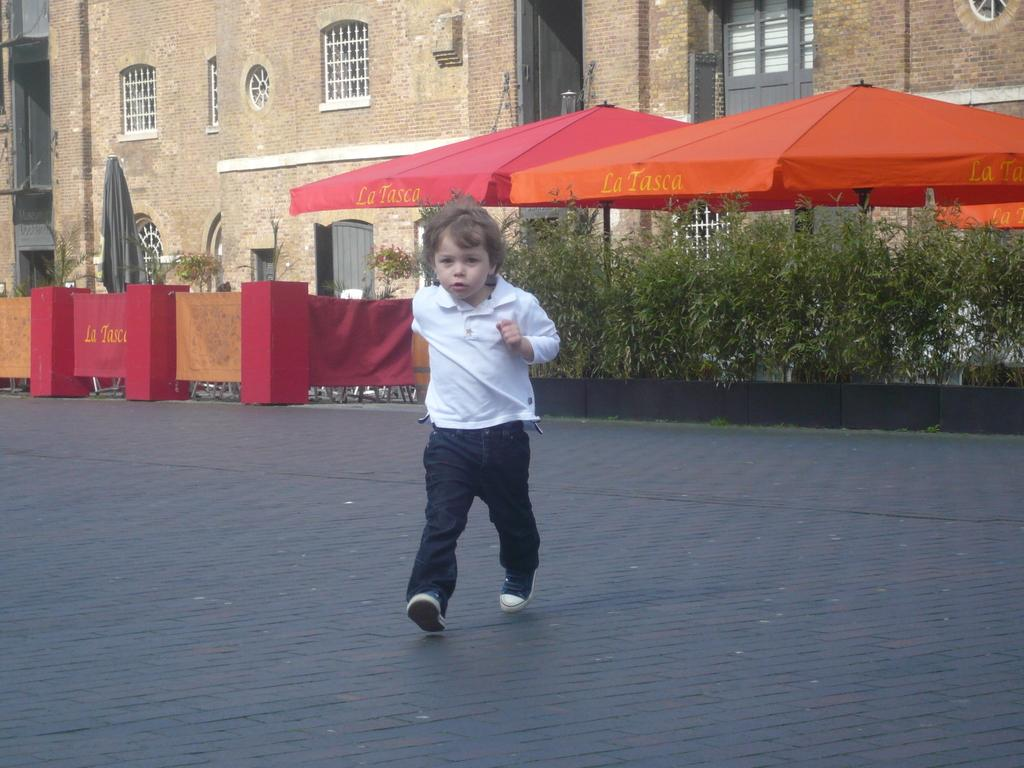Who or what is present in the image? There is a person in the image. What else can be seen in the image besides the person? There are many plants, two tents, and two buildings in the image. What is the name of the basketball machine in the image? There is no basketball machine present in the image. 